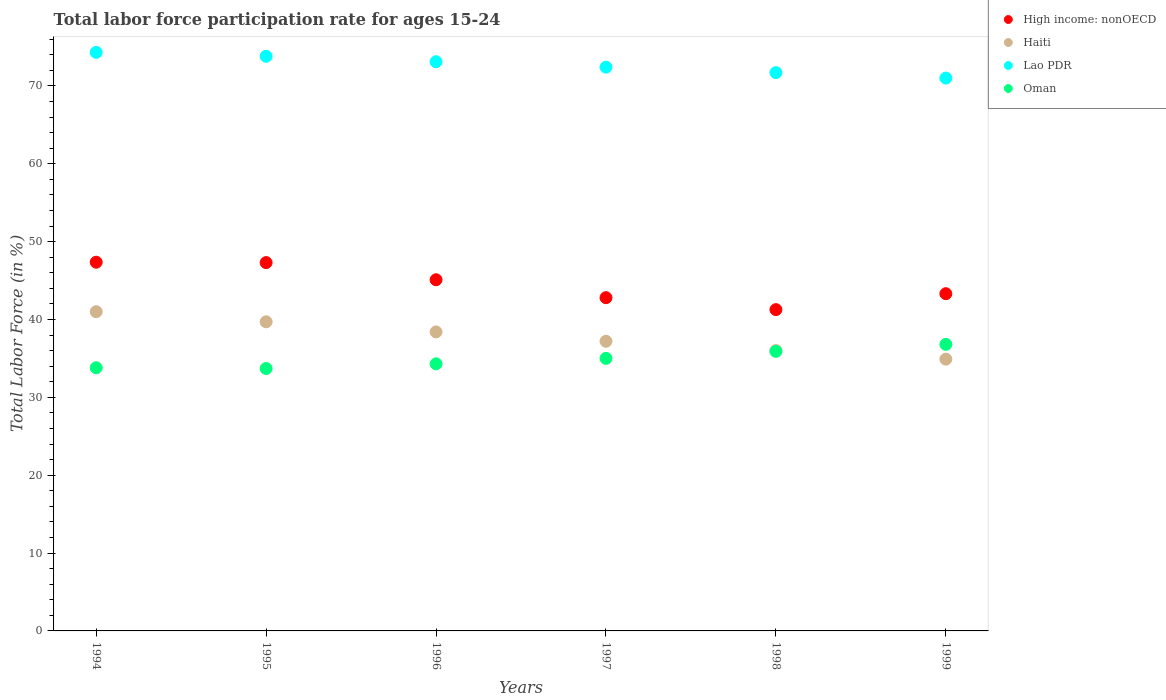How many different coloured dotlines are there?
Provide a short and direct response. 4. What is the labor force participation rate in Lao PDR in 1996?
Ensure brevity in your answer.  73.1. Across all years, what is the minimum labor force participation rate in Oman?
Provide a short and direct response. 33.7. In which year was the labor force participation rate in High income: nonOECD maximum?
Your answer should be compact. 1994. In which year was the labor force participation rate in Lao PDR minimum?
Provide a succinct answer. 1999. What is the total labor force participation rate in Lao PDR in the graph?
Keep it short and to the point. 436.3. What is the difference between the labor force participation rate in Haiti in 1995 and that in 1997?
Give a very brief answer. 2.5. What is the difference between the labor force participation rate in High income: nonOECD in 1995 and the labor force participation rate in Oman in 1999?
Give a very brief answer. 10.5. What is the average labor force participation rate in Lao PDR per year?
Offer a terse response. 72.72. In the year 1994, what is the difference between the labor force participation rate in High income: nonOECD and labor force participation rate in Lao PDR?
Your answer should be compact. -26.95. In how many years, is the labor force participation rate in Lao PDR greater than 14 %?
Provide a short and direct response. 6. What is the ratio of the labor force participation rate in Lao PDR in 1994 to that in 1999?
Ensure brevity in your answer.  1.05. What is the difference between the highest and the lowest labor force participation rate in Oman?
Your answer should be compact. 3.1. In how many years, is the labor force participation rate in Haiti greater than the average labor force participation rate in Haiti taken over all years?
Offer a terse response. 3. Is the sum of the labor force participation rate in Oman in 1996 and 1999 greater than the maximum labor force participation rate in Lao PDR across all years?
Provide a succinct answer. No. Is it the case that in every year, the sum of the labor force participation rate in High income: nonOECD and labor force participation rate in Haiti  is greater than the sum of labor force participation rate in Lao PDR and labor force participation rate in Oman?
Your response must be concise. No. Is the labor force participation rate in Oman strictly greater than the labor force participation rate in Haiti over the years?
Your answer should be very brief. No. Is the labor force participation rate in Lao PDR strictly less than the labor force participation rate in High income: nonOECD over the years?
Give a very brief answer. No. Does the graph contain any zero values?
Ensure brevity in your answer.  No. Does the graph contain grids?
Offer a terse response. No. How many legend labels are there?
Provide a short and direct response. 4. What is the title of the graph?
Offer a very short reply. Total labor force participation rate for ages 15-24. Does "Slovak Republic" appear as one of the legend labels in the graph?
Your answer should be very brief. No. What is the label or title of the X-axis?
Make the answer very short. Years. What is the Total Labor Force (in %) in High income: nonOECD in 1994?
Your response must be concise. 47.35. What is the Total Labor Force (in %) of Haiti in 1994?
Provide a succinct answer. 41. What is the Total Labor Force (in %) in Lao PDR in 1994?
Offer a very short reply. 74.3. What is the Total Labor Force (in %) in Oman in 1994?
Give a very brief answer. 33.8. What is the Total Labor Force (in %) of High income: nonOECD in 1995?
Give a very brief answer. 47.3. What is the Total Labor Force (in %) in Haiti in 1995?
Your answer should be compact. 39.7. What is the Total Labor Force (in %) of Lao PDR in 1995?
Your answer should be very brief. 73.8. What is the Total Labor Force (in %) of Oman in 1995?
Offer a very short reply. 33.7. What is the Total Labor Force (in %) of High income: nonOECD in 1996?
Provide a succinct answer. 45.1. What is the Total Labor Force (in %) of Haiti in 1996?
Offer a very short reply. 38.4. What is the Total Labor Force (in %) in Lao PDR in 1996?
Your response must be concise. 73.1. What is the Total Labor Force (in %) of Oman in 1996?
Give a very brief answer. 34.3. What is the Total Labor Force (in %) in High income: nonOECD in 1997?
Your response must be concise. 42.8. What is the Total Labor Force (in %) in Haiti in 1997?
Your response must be concise. 37.2. What is the Total Labor Force (in %) in Lao PDR in 1997?
Provide a short and direct response. 72.4. What is the Total Labor Force (in %) in Oman in 1997?
Make the answer very short. 35. What is the Total Labor Force (in %) of High income: nonOECD in 1998?
Your response must be concise. 41.26. What is the Total Labor Force (in %) in Lao PDR in 1998?
Provide a succinct answer. 71.7. What is the Total Labor Force (in %) in Oman in 1998?
Provide a succinct answer. 35.9. What is the Total Labor Force (in %) in High income: nonOECD in 1999?
Provide a short and direct response. 43.31. What is the Total Labor Force (in %) of Haiti in 1999?
Give a very brief answer. 34.9. What is the Total Labor Force (in %) in Oman in 1999?
Your answer should be very brief. 36.8. Across all years, what is the maximum Total Labor Force (in %) of High income: nonOECD?
Make the answer very short. 47.35. Across all years, what is the maximum Total Labor Force (in %) of Haiti?
Give a very brief answer. 41. Across all years, what is the maximum Total Labor Force (in %) of Lao PDR?
Offer a terse response. 74.3. Across all years, what is the maximum Total Labor Force (in %) of Oman?
Your answer should be compact. 36.8. Across all years, what is the minimum Total Labor Force (in %) in High income: nonOECD?
Offer a very short reply. 41.26. Across all years, what is the minimum Total Labor Force (in %) in Haiti?
Give a very brief answer. 34.9. Across all years, what is the minimum Total Labor Force (in %) in Lao PDR?
Offer a terse response. 71. Across all years, what is the minimum Total Labor Force (in %) of Oman?
Your answer should be very brief. 33.7. What is the total Total Labor Force (in %) of High income: nonOECD in the graph?
Offer a very short reply. 267.12. What is the total Total Labor Force (in %) in Haiti in the graph?
Make the answer very short. 227.2. What is the total Total Labor Force (in %) in Lao PDR in the graph?
Provide a succinct answer. 436.3. What is the total Total Labor Force (in %) in Oman in the graph?
Provide a short and direct response. 209.5. What is the difference between the Total Labor Force (in %) of High income: nonOECD in 1994 and that in 1995?
Make the answer very short. 0.05. What is the difference between the Total Labor Force (in %) in Haiti in 1994 and that in 1995?
Give a very brief answer. 1.3. What is the difference between the Total Labor Force (in %) of Oman in 1994 and that in 1995?
Keep it short and to the point. 0.1. What is the difference between the Total Labor Force (in %) in High income: nonOECD in 1994 and that in 1996?
Give a very brief answer. 2.25. What is the difference between the Total Labor Force (in %) of Lao PDR in 1994 and that in 1996?
Your answer should be compact. 1.2. What is the difference between the Total Labor Force (in %) in High income: nonOECD in 1994 and that in 1997?
Keep it short and to the point. 4.55. What is the difference between the Total Labor Force (in %) in Haiti in 1994 and that in 1997?
Ensure brevity in your answer.  3.8. What is the difference between the Total Labor Force (in %) of Lao PDR in 1994 and that in 1997?
Make the answer very short. 1.9. What is the difference between the Total Labor Force (in %) in Oman in 1994 and that in 1997?
Ensure brevity in your answer.  -1.2. What is the difference between the Total Labor Force (in %) of High income: nonOECD in 1994 and that in 1998?
Give a very brief answer. 6.09. What is the difference between the Total Labor Force (in %) of Haiti in 1994 and that in 1998?
Provide a short and direct response. 5. What is the difference between the Total Labor Force (in %) of High income: nonOECD in 1994 and that in 1999?
Provide a succinct answer. 4.04. What is the difference between the Total Labor Force (in %) of High income: nonOECD in 1995 and that in 1996?
Make the answer very short. 2.2. What is the difference between the Total Labor Force (in %) of High income: nonOECD in 1995 and that in 1997?
Offer a very short reply. 4.5. What is the difference between the Total Labor Force (in %) in Lao PDR in 1995 and that in 1997?
Provide a succinct answer. 1.4. What is the difference between the Total Labor Force (in %) in High income: nonOECD in 1995 and that in 1998?
Provide a short and direct response. 6.04. What is the difference between the Total Labor Force (in %) of Haiti in 1995 and that in 1998?
Your answer should be compact. 3.7. What is the difference between the Total Labor Force (in %) in Lao PDR in 1995 and that in 1998?
Provide a succinct answer. 2.1. What is the difference between the Total Labor Force (in %) of High income: nonOECD in 1995 and that in 1999?
Keep it short and to the point. 3.99. What is the difference between the Total Labor Force (in %) of Haiti in 1995 and that in 1999?
Give a very brief answer. 4.8. What is the difference between the Total Labor Force (in %) of High income: nonOECD in 1996 and that in 1997?
Your answer should be very brief. 2.3. What is the difference between the Total Labor Force (in %) of Oman in 1996 and that in 1997?
Your response must be concise. -0.7. What is the difference between the Total Labor Force (in %) in High income: nonOECD in 1996 and that in 1998?
Your answer should be very brief. 3.84. What is the difference between the Total Labor Force (in %) in Haiti in 1996 and that in 1998?
Provide a short and direct response. 2.4. What is the difference between the Total Labor Force (in %) of Oman in 1996 and that in 1998?
Offer a very short reply. -1.6. What is the difference between the Total Labor Force (in %) in High income: nonOECD in 1996 and that in 1999?
Offer a very short reply. 1.79. What is the difference between the Total Labor Force (in %) of Haiti in 1996 and that in 1999?
Ensure brevity in your answer.  3.5. What is the difference between the Total Labor Force (in %) in Lao PDR in 1996 and that in 1999?
Offer a very short reply. 2.1. What is the difference between the Total Labor Force (in %) of High income: nonOECD in 1997 and that in 1998?
Ensure brevity in your answer.  1.54. What is the difference between the Total Labor Force (in %) in Haiti in 1997 and that in 1998?
Your answer should be very brief. 1.2. What is the difference between the Total Labor Force (in %) of Oman in 1997 and that in 1998?
Provide a short and direct response. -0.9. What is the difference between the Total Labor Force (in %) in High income: nonOECD in 1997 and that in 1999?
Offer a very short reply. -0.51. What is the difference between the Total Labor Force (in %) of Oman in 1997 and that in 1999?
Offer a terse response. -1.8. What is the difference between the Total Labor Force (in %) in High income: nonOECD in 1998 and that in 1999?
Give a very brief answer. -2.05. What is the difference between the Total Labor Force (in %) of Haiti in 1998 and that in 1999?
Provide a succinct answer. 1.1. What is the difference between the Total Labor Force (in %) of Lao PDR in 1998 and that in 1999?
Your response must be concise. 0.7. What is the difference between the Total Labor Force (in %) of Oman in 1998 and that in 1999?
Offer a very short reply. -0.9. What is the difference between the Total Labor Force (in %) in High income: nonOECD in 1994 and the Total Labor Force (in %) in Haiti in 1995?
Provide a succinct answer. 7.65. What is the difference between the Total Labor Force (in %) of High income: nonOECD in 1994 and the Total Labor Force (in %) of Lao PDR in 1995?
Offer a very short reply. -26.45. What is the difference between the Total Labor Force (in %) in High income: nonOECD in 1994 and the Total Labor Force (in %) in Oman in 1995?
Your answer should be very brief. 13.65. What is the difference between the Total Labor Force (in %) in Haiti in 1994 and the Total Labor Force (in %) in Lao PDR in 1995?
Provide a succinct answer. -32.8. What is the difference between the Total Labor Force (in %) in Lao PDR in 1994 and the Total Labor Force (in %) in Oman in 1995?
Provide a short and direct response. 40.6. What is the difference between the Total Labor Force (in %) in High income: nonOECD in 1994 and the Total Labor Force (in %) in Haiti in 1996?
Give a very brief answer. 8.95. What is the difference between the Total Labor Force (in %) of High income: nonOECD in 1994 and the Total Labor Force (in %) of Lao PDR in 1996?
Make the answer very short. -25.75. What is the difference between the Total Labor Force (in %) in High income: nonOECD in 1994 and the Total Labor Force (in %) in Oman in 1996?
Offer a terse response. 13.05. What is the difference between the Total Labor Force (in %) in Haiti in 1994 and the Total Labor Force (in %) in Lao PDR in 1996?
Your response must be concise. -32.1. What is the difference between the Total Labor Force (in %) of Lao PDR in 1994 and the Total Labor Force (in %) of Oman in 1996?
Offer a terse response. 40. What is the difference between the Total Labor Force (in %) of High income: nonOECD in 1994 and the Total Labor Force (in %) of Haiti in 1997?
Keep it short and to the point. 10.15. What is the difference between the Total Labor Force (in %) in High income: nonOECD in 1994 and the Total Labor Force (in %) in Lao PDR in 1997?
Give a very brief answer. -25.05. What is the difference between the Total Labor Force (in %) of High income: nonOECD in 1994 and the Total Labor Force (in %) of Oman in 1997?
Your answer should be compact. 12.35. What is the difference between the Total Labor Force (in %) in Haiti in 1994 and the Total Labor Force (in %) in Lao PDR in 1997?
Your answer should be compact. -31.4. What is the difference between the Total Labor Force (in %) in Haiti in 1994 and the Total Labor Force (in %) in Oman in 1997?
Offer a terse response. 6. What is the difference between the Total Labor Force (in %) in Lao PDR in 1994 and the Total Labor Force (in %) in Oman in 1997?
Ensure brevity in your answer.  39.3. What is the difference between the Total Labor Force (in %) of High income: nonOECD in 1994 and the Total Labor Force (in %) of Haiti in 1998?
Keep it short and to the point. 11.35. What is the difference between the Total Labor Force (in %) in High income: nonOECD in 1994 and the Total Labor Force (in %) in Lao PDR in 1998?
Offer a terse response. -24.35. What is the difference between the Total Labor Force (in %) of High income: nonOECD in 1994 and the Total Labor Force (in %) of Oman in 1998?
Your answer should be very brief. 11.45. What is the difference between the Total Labor Force (in %) in Haiti in 1994 and the Total Labor Force (in %) in Lao PDR in 1998?
Your answer should be very brief. -30.7. What is the difference between the Total Labor Force (in %) in Lao PDR in 1994 and the Total Labor Force (in %) in Oman in 1998?
Ensure brevity in your answer.  38.4. What is the difference between the Total Labor Force (in %) of High income: nonOECD in 1994 and the Total Labor Force (in %) of Haiti in 1999?
Your answer should be compact. 12.45. What is the difference between the Total Labor Force (in %) of High income: nonOECD in 1994 and the Total Labor Force (in %) of Lao PDR in 1999?
Your answer should be compact. -23.65. What is the difference between the Total Labor Force (in %) in High income: nonOECD in 1994 and the Total Labor Force (in %) in Oman in 1999?
Provide a succinct answer. 10.55. What is the difference between the Total Labor Force (in %) of Haiti in 1994 and the Total Labor Force (in %) of Lao PDR in 1999?
Make the answer very short. -30. What is the difference between the Total Labor Force (in %) of Haiti in 1994 and the Total Labor Force (in %) of Oman in 1999?
Keep it short and to the point. 4.2. What is the difference between the Total Labor Force (in %) of Lao PDR in 1994 and the Total Labor Force (in %) of Oman in 1999?
Your response must be concise. 37.5. What is the difference between the Total Labor Force (in %) in High income: nonOECD in 1995 and the Total Labor Force (in %) in Haiti in 1996?
Provide a succinct answer. 8.9. What is the difference between the Total Labor Force (in %) of High income: nonOECD in 1995 and the Total Labor Force (in %) of Lao PDR in 1996?
Offer a very short reply. -25.8. What is the difference between the Total Labor Force (in %) of High income: nonOECD in 1995 and the Total Labor Force (in %) of Oman in 1996?
Keep it short and to the point. 13. What is the difference between the Total Labor Force (in %) of Haiti in 1995 and the Total Labor Force (in %) of Lao PDR in 1996?
Your response must be concise. -33.4. What is the difference between the Total Labor Force (in %) in Lao PDR in 1995 and the Total Labor Force (in %) in Oman in 1996?
Provide a succinct answer. 39.5. What is the difference between the Total Labor Force (in %) in High income: nonOECD in 1995 and the Total Labor Force (in %) in Haiti in 1997?
Make the answer very short. 10.1. What is the difference between the Total Labor Force (in %) of High income: nonOECD in 1995 and the Total Labor Force (in %) of Lao PDR in 1997?
Offer a terse response. -25.1. What is the difference between the Total Labor Force (in %) in High income: nonOECD in 1995 and the Total Labor Force (in %) in Oman in 1997?
Your response must be concise. 12.3. What is the difference between the Total Labor Force (in %) in Haiti in 1995 and the Total Labor Force (in %) in Lao PDR in 1997?
Provide a succinct answer. -32.7. What is the difference between the Total Labor Force (in %) in Haiti in 1995 and the Total Labor Force (in %) in Oman in 1997?
Make the answer very short. 4.7. What is the difference between the Total Labor Force (in %) in Lao PDR in 1995 and the Total Labor Force (in %) in Oman in 1997?
Keep it short and to the point. 38.8. What is the difference between the Total Labor Force (in %) in High income: nonOECD in 1995 and the Total Labor Force (in %) in Haiti in 1998?
Ensure brevity in your answer.  11.3. What is the difference between the Total Labor Force (in %) of High income: nonOECD in 1995 and the Total Labor Force (in %) of Lao PDR in 1998?
Keep it short and to the point. -24.4. What is the difference between the Total Labor Force (in %) in High income: nonOECD in 1995 and the Total Labor Force (in %) in Oman in 1998?
Provide a short and direct response. 11.4. What is the difference between the Total Labor Force (in %) in Haiti in 1995 and the Total Labor Force (in %) in Lao PDR in 1998?
Provide a succinct answer. -32. What is the difference between the Total Labor Force (in %) in Haiti in 1995 and the Total Labor Force (in %) in Oman in 1998?
Offer a very short reply. 3.8. What is the difference between the Total Labor Force (in %) in Lao PDR in 1995 and the Total Labor Force (in %) in Oman in 1998?
Give a very brief answer. 37.9. What is the difference between the Total Labor Force (in %) in High income: nonOECD in 1995 and the Total Labor Force (in %) in Haiti in 1999?
Your answer should be very brief. 12.4. What is the difference between the Total Labor Force (in %) in High income: nonOECD in 1995 and the Total Labor Force (in %) in Lao PDR in 1999?
Provide a succinct answer. -23.7. What is the difference between the Total Labor Force (in %) of High income: nonOECD in 1995 and the Total Labor Force (in %) of Oman in 1999?
Your response must be concise. 10.5. What is the difference between the Total Labor Force (in %) of Haiti in 1995 and the Total Labor Force (in %) of Lao PDR in 1999?
Give a very brief answer. -31.3. What is the difference between the Total Labor Force (in %) in High income: nonOECD in 1996 and the Total Labor Force (in %) in Haiti in 1997?
Your answer should be compact. 7.9. What is the difference between the Total Labor Force (in %) in High income: nonOECD in 1996 and the Total Labor Force (in %) in Lao PDR in 1997?
Your response must be concise. -27.3. What is the difference between the Total Labor Force (in %) of High income: nonOECD in 1996 and the Total Labor Force (in %) of Oman in 1997?
Your answer should be very brief. 10.1. What is the difference between the Total Labor Force (in %) of Haiti in 1996 and the Total Labor Force (in %) of Lao PDR in 1997?
Your answer should be very brief. -34. What is the difference between the Total Labor Force (in %) of Haiti in 1996 and the Total Labor Force (in %) of Oman in 1997?
Your answer should be very brief. 3.4. What is the difference between the Total Labor Force (in %) of Lao PDR in 1996 and the Total Labor Force (in %) of Oman in 1997?
Provide a short and direct response. 38.1. What is the difference between the Total Labor Force (in %) of High income: nonOECD in 1996 and the Total Labor Force (in %) of Haiti in 1998?
Your answer should be compact. 9.1. What is the difference between the Total Labor Force (in %) in High income: nonOECD in 1996 and the Total Labor Force (in %) in Lao PDR in 1998?
Provide a short and direct response. -26.6. What is the difference between the Total Labor Force (in %) in High income: nonOECD in 1996 and the Total Labor Force (in %) in Oman in 1998?
Provide a short and direct response. 9.2. What is the difference between the Total Labor Force (in %) in Haiti in 1996 and the Total Labor Force (in %) in Lao PDR in 1998?
Your answer should be very brief. -33.3. What is the difference between the Total Labor Force (in %) of Haiti in 1996 and the Total Labor Force (in %) of Oman in 1998?
Ensure brevity in your answer.  2.5. What is the difference between the Total Labor Force (in %) of Lao PDR in 1996 and the Total Labor Force (in %) of Oman in 1998?
Keep it short and to the point. 37.2. What is the difference between the Total Labor Force (in %) in High income: nonOECD in 1996 and the Total Labor Force (in %) in Haiti in 1999?
Give a very brief answer. 10.2. What is the difference between the Total Labor Force (in %) in High income: nonOECD in 1996 and the Total Labor Force (in %) in Lao PDR in 1999?
Offer a terse response. -25.9. What is the difference between the Total Labor Force (in %) of High income: nonOECD in 1996 and the Total Labor Force (in %) of Oman in 1999?
Give a very brief answer. 8.3. What is the difference between the Total Labor Force (in %) in Haiti in 1996 and the Total Labor Force (in %) in Lao PDR in 1999?
Make the answer very short. -32.6. What is the difference between the Total Labor Force (in %) in Haiti in 1996 and the Total Labor Force (in %) in Oman in 1999?
Ensure brevity in your answer.  1.6. What is the difference between the Total Labor Force (in %) of Lao PDR in 1996 and the Total Labor Force (in %) of Oman in 1999?
Your answer should be very brief. 36.3. What is the difference between the Total Labor Force (in %) in High income: nonOECD in 1997 and the Total Labor Force (in %) in Haiti in 1998?
Your response must be concise. 6.8. What is the difference between the Total Labor Force (in %) in High income: nonOECD in 1997 and the Total Labor Force (in %) in Lao PDR in 1998?
Your response must be concise. -28.9. What is the difference between the Total Labor Force (in %) of High income: nonOECD in 1997 and the Total Labor Force (in %) of Oman in 1998?
Give a very brief answer. 6.9. What is the difference between the Total Labor Force (in %) of Haiti in 1997 and the Total Labor Force (in %) of Lao PDR in 1998?
Offer a terse response. -34.5. What is the difference between the Total Labor Force (in %) of Lao PDR in 1997 and the Total Labor Force (in %) of Oman in 1998?
Make the answer very short. 36.5. What is the difference between the Total Labor Force (in %) in High income: nonOECD in 1997 and the Total Labor Force (in %) in Haiti in 1999?
Give a very brief answer. 7.9. What is the difference between the Total Labor Force (in %) in High income: nonOECD in 1997 and the Total Labor Force (in %) in Lao PDR in 1999?
Your answer should be very brief. -28.2. What is the difference between the Total Labor Force (in %) of High income: nonOECD in 1997 and the Total Labor Force (in %) of Oman in 1999?
Ensure brevity in your answer.  6. What is the difference between the Total Labor Force (in %) in Haiti in 1997 and the Total Labor Force (in %) in Lao PDR in 1999?
Ensure brevity in your answer.  -33.8. What is the difference between the Total Labor Force (in %) in Haiti in 1997 and the Total Labor Force (in %) in Oman in 1999?
Your answer should be compact. 0.4. What is the difference between the Total Labor Force (in %) in Lao PDR in 1997 and the Total Labor Force (in %) in Oman in 1999?
Your answer should be compact. 35.6. What is the difference between the Total Labor Force (in %) of High income: nonOECD in 1998 and the Total Labor Force (in %) of Haiti in 1999?
Give a very brief answer. 6.36. What is the difference between the Total Labor Force (in %) in High income: nonOECD in 1998 and the Total Labor Force (in %) in Lao PDR in 1999?
Provide a short and direct response. -29.74. What is the difference between the Total Labor Force (in %) in High income: nonOECD in 1998 and the Total Labor Force (in %) in Oman in 1999?
Offer a terse response. 4.46. What is the difference between the Total Labor Force (in %) of Haiti in 1998 and the Total Labor Force (in %) of Lao PDR in 1999?
Your response must be concise. -35. What is the difference between the Total Labor Force (in %) of Lao PDR in 1998 and the Total Labor Force (in %) of Oman in 1999?
Offer a terse response. 34.9. What is the average Total Labor Force (in %) of High income: nonOECD per year?
Provide a succinct answer. 44.52. What is the average Total Labor Force (in %) in Haiti per year?
Provide a succinct answer. 37.87. What is the average Total Labor Force (in %) in Lao PDR per year?
Offer a very short reply. 72.72. What is the average Total Labor Force (in %) in Oman per year?
Ensure brevity in your answer.  34.92. In the year 1994, what is the difference between the Total Labor Force (in %) in High income: nonOECD and Total Labor Force (in %) in Haiti?
Keep it short and to the point. 6.35. In the year 1994, what is the difference between the Total Labor Force (in %) of High income: nonOECD and Total Labor Force (in %) of Lao PDR?
Provide a short and direct response. -26.95. In the year 1994, what is the difference between the Total Labor Force (in %) of High income: nonOECD and Total Labor Force (in %) of Oman?
Your answer should be compact. 13.55. In the year 1994, what is the difference between the Total Labor Force (in %) in Haiti and Total Labor Force (in %) in Lao PDR?
Provide a short and direct response. -33.3. In the year 1994, what is the difference between the Total Labor Force (in %) of Lao PDR and Total Labor Force (in %) of Oman?
Give a very brief answer. 40.5. In the year 1995, what is the difference between the Total Labor Force (in %) of High income: nonOECD and Total Labor Force (in %) of Haiti?
Your response must be concise. 7.6. In the year 1995, what is the difference between the Total Labor Force (in %) of High income: nonOECD and Total Labor Force (in %) of Lao PDR?
Keep it short and to the point. -26.5. In the year 1995, what is the difference between the Total Labor Force (in %) of High income: nonOECD and Total Labor Force (in %) of Oman?
Your answer should be compact. 13.6. In the year 1995, what is the difference between the Total Labor Force (in %) in Haiti and Total Labor Force (in %) in Lao PDR?
Your answer should be very brief. -34.1. In the year 1995, what is the difference between the Total Labor Force (in %) of Haiti and Total Labor Force (in %) of Oman?
Make the answer very short. 6. In the year 1995, what is the difference between the Total Labor Force (in %) in Lao PDR and Total Labor Force (in %) in Oman?
Your response must be concise. 40.1. In the year 1996, what is the difference between the Total Labor Force (in %) in High income: nonOECD and Total Labor Force (in %) in Haiti?
Make the answer very short. 6.7. In the year 1996, what is the difference between the Total Labor Force (in %) of High income: nonOECD and Total Labor Force (in %) of Lao PDR?
Give a very brief answer. -28. In the year 1996, what is the difference between the Total Labor Force (in %) in High income: nonOECD and Total Labor Force (in %) in Oman?
Give a very brief answer. 10.8. In the year 1996, what is the difference between the Total Labor Force (in %) of Haiti and Total Labor Force (in %) of Lao PDR?
Offer a terse response. -34.7. In the year 1996, what is the difference between the Total Labor Force (in %) in Haiti and Total Labor Force (in %) in Oman?
Offer a terse response. 4.1. In the year 1996, what is the difference between the Total Labor Force (in %) in Lao PDR and Total Labor Force (in %) in Oman?
Offer a terse response. 38.8. In the year 1997, what is the difference between the Total Labor Force (in %) of High income: nonOECD and Total Labor Force (in %) of Haiti?
Offer a very short reply. 5.6. In the year 1997, what is the difference between the Total Labor Force (in %) in High income: nonOECD and Total Labor Force (in %) in Lao PDR?
Offer a very short reply. -29.6. In the year 1997, what is the difference between the Total Labor Force (in %) of High income: nonOECD and Total Labor Force (in %) of Oman?
Give a very brief answer. 7.8. In the year 1997, what is the difference between the Total Labor Force (in %) in Haiti and Total Labor Force (in %) in Lao PDR?
Offer a terse response. -35.2. In the year 1997, what is the difference between the Total Labor Force (in %) of Lao PDR and Total Labor Force (in %) of Oman?
Keep it short and to the point. 37.4. In the year 1998, what is the difference between the Total Labor Force (in %) of High income: nonOECD and Total Labor Force (in %) of Haiti?
Give a very brief answer. 5.26. In the year 1998, what is the difference between the Total Labor Force (in %) in High income: nonOECD and Total Labor Force (in %) in Lao PDR?
Provide a short and direct response. -30.44. In the year 1998, what is the difference between the Total Labor Force (in %) of High income: nonOECD and Total Labor Force (in %) of Oman?
Your answer should be compact. 5.36. In the year 1998, what is the difference between the Total Labor Force (in %) in Haiti and Total Labor Force (in %) in Lao PDR?
Your answer should be compact. -35.7. In the year 1998, what is the difference between the Total Labor Force (in %) of Lao PDR and Total Labor Force (in %) of Oman?
Offer a terse response. 35.8. In the year 1999, what is the difference between the Total Labor Force (in %) of High income: nonOECD and Total Labor Force (in %) of Haiti?
Provide a short and direct response. 8.41. In the year 1999, what is the difference between the Total Labor Force (in %) of High income: nonOECD and Total Labor Force (in %) of Lao PDR?
Ensure brevity in your answer.  -27.69. In the year 1999, what is the difference between the Total Labor Force (in %) of High income: nonOECD and Total Labor Force (in %) of Oman?
Ensure brevity in your answer.  6.51. In the year 1999, what is the difference between the Total Labor Force (in %) in Haiti and Total Labor Force (in %) in Lao PDR?
Offer a terse response. -36.1. In the year 1999, what is the difference between the Total Labor Force (in %) in Lao PDR and Total Labor Force (in %) in Oman?
Offer a very short reply. 34.2. What is the ratio of the Total Labor Force (in %) of Haiti in 1994 to that in 1995?
Give a very brief answer. 1.03. What is the ratio of the Total Labor Force (in %) of Lao PDR in 1994 to that in 1995?
Your answer should be very brief. 1.01. What is the ratio of the Total Labor Force (in %) in Oman in 1994 to that in 1995?
Provide a short and direct response. 1. What is the ratio of the Total Labor Force (in %) in High income: nonOECD in 1994 to that in 1996?
Your answer should be compact. 1.05. What is the ratio of the Total Labor Force (in %) of Haiti in 1994 to that in 1996?
Your answer should be compact. 1.07. What is the ratio of the Total Labor Force (in %) of Lao PDR in 1994 to that in 1996?
Give a very brief answer. 1.02. What is the ratio of the Total Labor Force (in %) in Oman in 1994 to that in 1996?
Ensure brevity in your answer.  0.99. What is the ratio of the Total Labor Force (in %) in High income: nonOECD in 1994 to that in 1997?
Your answer should be very brief. 1.11. What is the ratio of the Total Labor Force (in %) of Haiti in 1994 to that in 1997?
Offer a very short reply. 1.1. What is the ratio of the Total Labor Force (in %) in Lao PDR in 1994 to that in 1997?
Provide a succinct answer. 1.03. What is the ratio of the Total Labor Force (in %) of Oman in 1994 to that in 1997?
Offer a terse response. 0.97. What is the ratio of the Total Labor Force (in %) of High income: nonOECD in 1994 to that in 1998?
Your answer should be very brief. 1.15. What is the ratio of the Total Labor Force (in %) of Haiti in 1994 to that in 1998?
Ensure brevity in your answer.  1.14. What is the ratio of the Total Labor Force (in %) in Lao PDR in 1994 to that in 1998?
Your answer should be very brief. 1.04. What is the ratio of the Total Labor Force (in %) in Oman in 1994 to that in 1998?
Your answer should be very brief. 0.94. What is the ratio of the Total Labor Force (in %) in High income: nonOECD in 1994 to that in 1999?
Offer a terse response. 1.09. What is the ratio of the Total Labor Force (in %) in Haiti in 1994 to that in 1999?
Your answer should be very brief. 1.17. What is the ratio of the Total Labor Force (in %) of Lao PDR in 1994 to that in 1999?
Provide a succinct answer. 1.05. What is the ratio of the Total Labor Force (in %) in Oman in 1994 to that in 1999?
Provide a short and direct response. 0.92. What is the ratio of the Total Labor Force (in %) of High income: nonOECD in 1995 to that in 1996?
Offer a terse response. 1.05. What is the ratio of the Total Labor Force (in %) in Haiti in 1995 to that in 1996?
Make the answer very short. 1.03. What is the ratio of the Total Labor Force (in %) of Lao PDR in 1995 to that in 1996?
Provide a short and direct response. 1.01. What is the ratio of the Total Labor Force (in %) of Oman in 1995 to that in 1996?
Give a very brief answer. 0.98. What is the ratio of the Total Labor Force (in %) in High income: nonOECD in 1995 to that in 1997?
Your response must be concise. 1.11. What is the ratio of the Total Labor Force (in %) in Haiti in 1995 to that in 1997?
Keep it short and to the point. 1.07. What is the ratio of the Total Labor Force (in %) of Lao PDR in 1995 to that in 1997?
Keep it short and to the point. 1.02. What is the ratio of the Total Labor Force (in %) of Oman in 1995 to that in 1997?
Provide a short and direct response. 0.96. What is the ratio of the Total Labor Force (in %) of High income: nonOECD in 1995 to that in 1998?
Keep it short and to the point. 1.15. What is the ratio of the Total Labor Force (in %) in Haiti in 1995 to that in 1998?
Keep it short and to the point. 1.1. What is the ratio of the Total Labor Force (in %) of Lao PDR in 1995 to that in 1998?
Give a very brief answer. 1.03. What is the ratio of the Total Labor Force (in %) of Oman in 1995 to that in 1998?
Provide a short and direct response. 0.94. What is the ratio of the Total Labor Force (in %) in High income: nonOECD in 1995 to that in 1999?
Offer a very short reply. 1.09. What is the ratio of the Total Labor Force (in %) in Haiti in 1995 to that in 1999?
Offer a very short reply. 1.14. What is the ratio of the Total Labor Force (in %) of Lao PDR in 1995 to that in 1999?
Your response must be concise. 1.04. What is the ratio of the Total Labor Force (in %) of Oman in 1995 to that in 1999?
Offer a very short reply. 0.92. What is the ratio of the Total Labor Force (in %) in High income: nonOECD in 1996 to that in 1997?
Ensure brevity in your answer.  1.05. What is the ratio of the Total Labor Force (in %) in Haiti in 1996 to that in 1997?
Offer a very short reply. 1.03. What is the ratio of the Total Labor Force (in %) of Lao PDR in 1996 to that in 1997?
Make the answer very short. 1.01. What is the ratio of the Total Labor Force (in %) in High income: nonOECD in 1996 to that in 1998?
Your answer should be compact. 1.09. What is the ratio of the Total Labor Force (in %) in Haiti in 1996 to that in 1998?
Ensure brevity in your answer.  1.07. What is the ratio of the Total Labor Force (in %) of Lao PDR in 1996 to that in 1998?
Make the answer very short. 1.02. What is the ratio of the Total Labor Force (in %) of Oman in 1996 to that in 1998?
Ensure brevity in your answer.  0.96. What is the ratio of the Total Labor Force (in %) in High income: nonOECD in 1996 to that in 1999?
Your response must be concise. 1.04. What is the ratio of the Total Labor Force (in %) of Haiti in 1996 to that in 1999?
Make the answer very short. 1.1. What is the ratio of the Total Labor Force (in %) of Lao PDR in 1996 to that in 1999?
Ensure brevity in your answer.  1.03. What is the ratio of the Total Labor Force (in %) in Oman in 1996 to that in 1999?
Ensure brevity in your answer.  0.93. What is the ratio of the Total Labor Force (in %) in High income: nonOECD in 1997 to that in 1998?
Ensure brevity in your answer.  1.04. What is the ratio of the Total Labor Force (in %) of Lao PDR in 1997 to that in 1998?
Your answer should be compact. 1.01. What is the ratio of the Total Labor Force (in %) in Oman in 1997 to that in 1998?
Provide a succinct answer. 0.97. What is the ratio of the Total Labor Force (in %) in Haiti in 1997 to that in 1999?
Your answer should be compact. 1.07. What is the ratio of the Total Labor Force (in %) in Lao PDR in 1997 to that in 1999?
Give a very brief answer. 1.02. What is the ratio of the Total Labor Force (in %) of Oman in 1997 to that in 1999?
Offer a very short reply. 0.95. What is the ratio of the Total Labor Force (in %) in High income: nonOECD in 1998 to that in 1999?
Your answer should be compact. 0.95. What is the ratio of the Total Labor Force (in %) of Haiti in 1998 to that in 1999?
Make the answer very short. 1.03. What is the ratio of the Total Labor Force (in %) of Lao PDR in 1998 to that in 1999?
Your answer should be very brief. 1.01. What is the ratio of the Total Labor Force (in %) of Oman in 1998 to that in 1999?
Give a very brief answer. 0.98. What is the difference between the highest and the second highest Total Labor Force (in %) in High income: nonOECD?
Your response must be concise. 0.05. What is the difference between the highest and the second highest Total Labor Force (in %) of Haiti?
Give a very brief answer. 1.3. What is the difference between the highest and the lowest Total Labor Force (in %) of High income: nonOECD?
Keep it short and to the point. 6.09. What is the difference between the highest and the lowest Total Labor Force (in %) in Haiti?
Offer a terse response. 6.1. What is the difference between the highest and the lowest Total Labor Force (in %) in Oman?
Your answer should be compact. 3.1. 